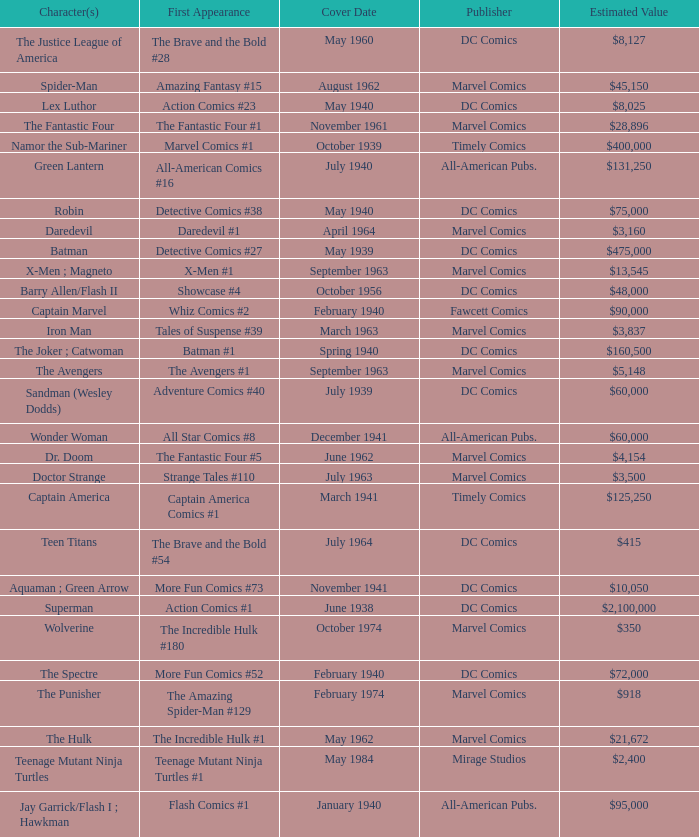Parse the full table. {'header': ['Character(s)', 'First Appearance', 'Cover Date', 'Publisher', 'Estimated Value'], 'rows': [['The Justice League of America', 'The Brave and the Bold #28', 'May 1960', 'DC Comics', '$8,127'], ['Spider-Man', 'Amazing Fantasy #15', 'August 1962', 'Marvel Comics', '$45,150'], ['Lex Luthor', 'Action Comics #23', 'May 1940', 'DC Comics', '$8,025'], ['The Fantastic Four', 'The Fantastic Four #1', 'November 1961', 'Marvel Comics', '$28,896'], ['Namor the Sub-Mariner', 'Marvel Comics #1', 'October 1939', 'Timely Comics', '$400,000'], ['Green Lantern', 'All-American Comics #16', 'July 1940', 'All-American Pubs.', '$131,250'], ['Robin', 'Detective Comics #38', 'May 1940', 'DC Comics', '$75,000'], ['Daredevil', 'Daredevil #1', 'April 1964', 'Marvel Comics', '$3,160'], ['Batman', 'Detective Comics #27', 'May 1939', 'DC Comics', '$475,000'], ['X-Men ; Magneto', 'X-Men #1', 'September 1963', 'Marvel Comics', '$13,545'], ['Barry Allen/Flash II', 'Showcase #4', 'October 1956', 'DC Comics', '$48,000'], ['Captain Marvel', 'Whiz Comics #2', 'February 1940', 'Fawcett Comics', '$90,000'], ['Iron Man', 'Tales of Suspense #39', 'March 1963', 'Marvel Comics', '$3,837'], ['The Joker ; Catwoman', 'Batman #1', 'Spring 1940', 'DC Comics', '$160,500'], ['The Avengers', 'The Avengers #1', 'September 1963', 'Marvel Comics', '$5,148'], ['Sandman (Wesley Dodds)', 'Adventure Comics #40', 'July 1939', 'DC Comics', '$60,000'], ['Wonder Woman', 'All Star Comics #8', 'December 1941', 'All-American Pubs.', '$60,000'], ['Dr. Doom', 'The Fantastic Four #5', 'June 1962', 'Marvel Comics', '$4,154'], ['Doctor Strange', 'Strange Tales #110', 'July 1963', 'Marvel Comics', '$3,500'], ['Captain America', 'Captain America Comics #1', 'March 1941', 'Timely Comics', '$125,250'], ['Teen Titans', 'The Brave and the Bold #54', 'July 1964', 'DC Comics', '$415'], ['Aquaman ; Green Arrow', 'More Fun Comics #73', 'November 1941', 'DC Comics', '$10,050'], ['Superman', 'Action Comics #1', 'June 1938', 'DC Comics', '$2,100,000'], ['Wolverine', 'The Incredible Hulk #180', 'October 1974', 'Marvel Comics', '$350'], ['The Spectre', 'More Fun Comics #52', 'February 1940', 'DC Comics', '$72,000'], ['The Punisher', 'The Amazing Spider-Man #129', 'February 1974', 'Marvel Comics', '$918'], ['The Hulk', 'The Incredible Hulk #1', 'May 1962', 'Marvel Comics', '$21,672'], ['Teenage Mutant Ninja Turtles', 'Teenage Mutant Ninja Turtles #1', 'May 1984', 'Mirage Studios', '$2,400'], ['Jay Garrick/Flash I ; Hawkman', 'Flash Comics #1', 'January 1940', 'All-American Pubs.', '$95,000']]} What is Action Comics #1's estimated value? $2,100,000. 